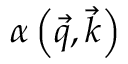<formula> <loc_0><loc_0><loc_500><loc_500>\alpha \left ( \vec { q } , \vec { k } \right )</formula> 